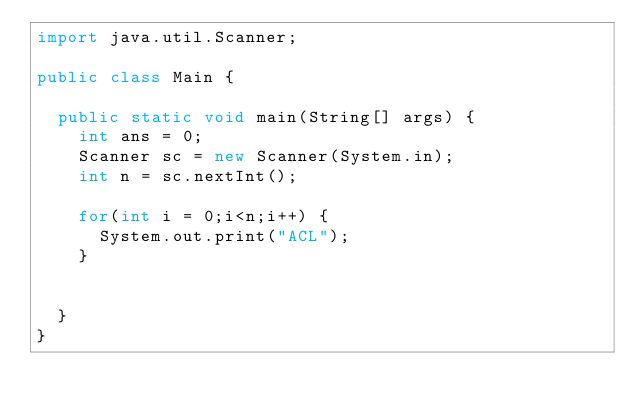Convert code to text. <code><loc_0><loc_0><loc_500><loc_500><_Java_>import java.util.Scanner;

public class Main {

	public static void main(String[] args) {
		int ans = 0;
		Scanner sc = new Scanner(System.in);
		int n = sc.nextInt();
		
		for(int i = 0;i<n;i++) {
			System.out.print("ACL");
		}
		
		
	}
}
</code> 